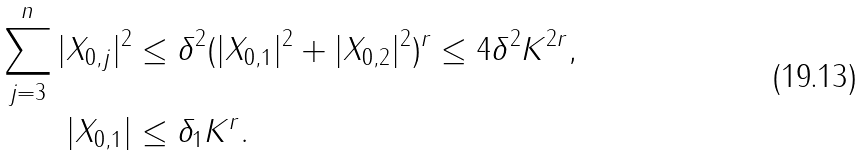Convert formula to latex. <formula><loc_0><loc_0><loc_500><loc_500>\sum _ { j = 3 } ^ { n } | X _ { 0 , j } | ^ { 2 } & \leq \delta ^ { 2 } ( | X _ { 0 , 1 } | ^ { 2 } + | X _ { 0 , 2 } | ^ { 2 } ) ^ { r } \leq 4 \delta ^ { 2 } K ^ { 2 r } , \\ | X _ { 0 , 1 } | & \leq \delta _ { 1 } K ^ { r } .</formula> 